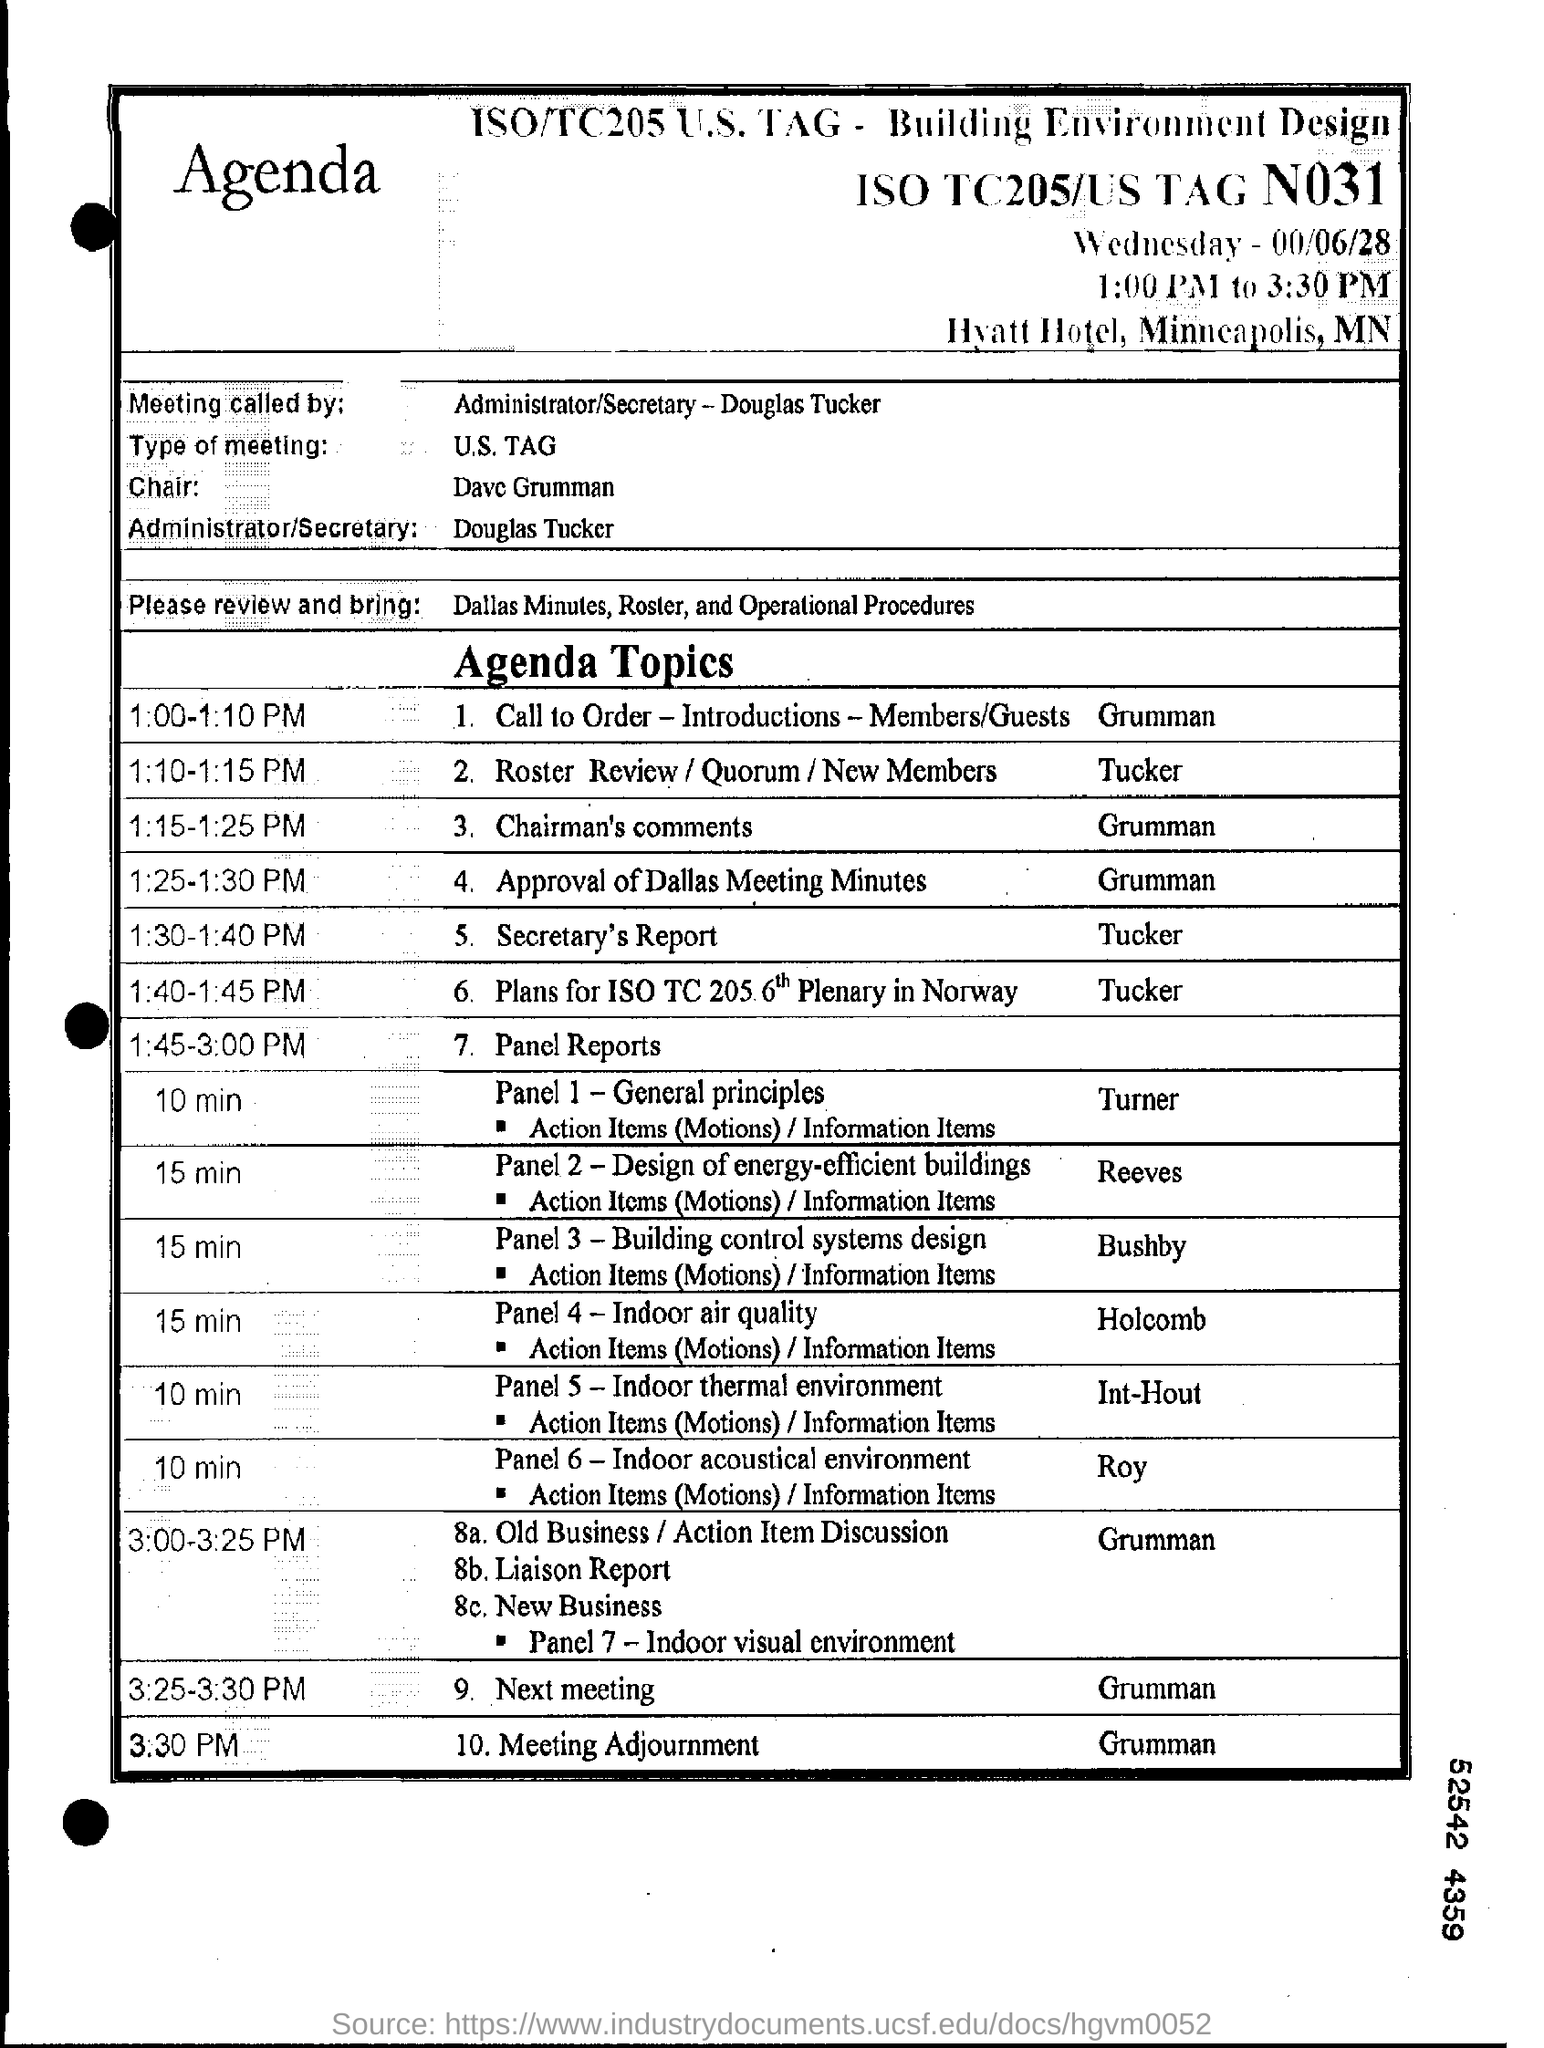What is the name of chair mentioned ?
Give a very brief answer. Dave grumman. What is the name of administrator/secretary mentioned ?
Your answer should be compact. Douglas tucker. 